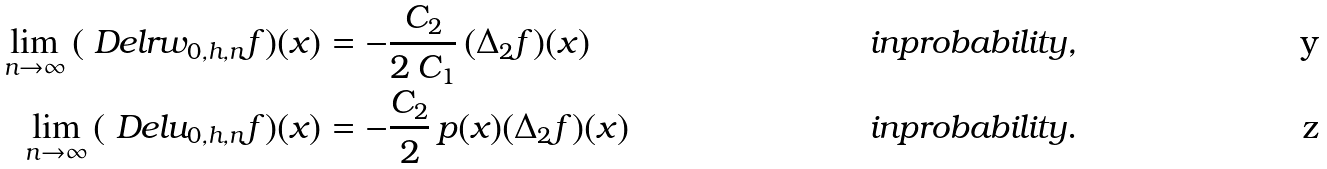<formula> <loc_0><loc_0><loc_500><loc_500>\lim _ { n \rightarrow \infty } \, ( \ D e l r w _ { 0 , h , n } f ) ( x ) & = - \frac { C _ { 2 } } { 2 \, C _ { 1 } } \, ( \Delta _ { 2 } f ) ( x ) & & i n p r o b a b i l i t y , \\ \lim _ { n \rightarrow \infty } \, ( \ D e l u _ { 0 , h , n } f ) ( x ) & = - \frac { C _ { 2 } } { 2 } \, p ( x ) ( \Delta _ { 2 } f ) ( x ) & & i n p r o b a b i l i t y .</formula> 